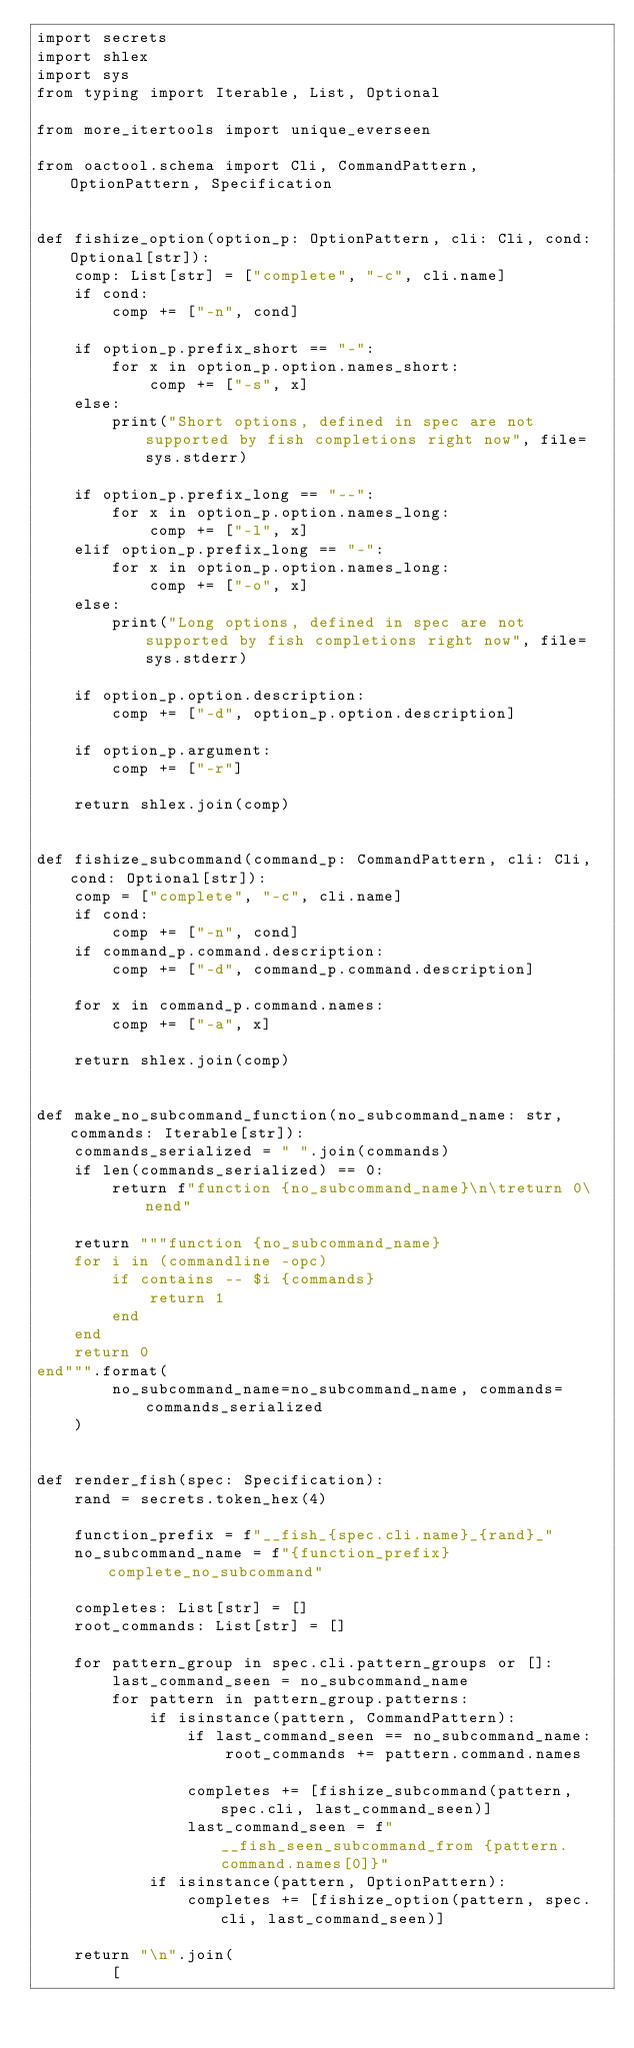<code> <loc_0><loc_0><loc_500><loc_500><_Python_>import secrets
import shlex
import sys
from typing import Iterable, List, Optional

from more_itertools import unique_everseen

from oactool.schema import Cli, CommandPattern, OptionPattern, Specification


def fishize_option(option_p: OptionPattern, cli: Cli, cond: Optional[str]):
    comp: List[str] = ["complete", "-c", cli.name]
    if cond:
        comp += ["-n", cond]

    if option_p.prefix_short == "-":
        for x in option_p.option.names_short:
            comp += ["-s", x]
    else:
        print("Short options, defined in spec are not supported by fish completions right now", file=sys.stderr)

    if option_p.prefix_long == "--":
        for x in option_p.option.names_long:
            comp += ["-l", x]
    elif option_p.prefix_long == "-":
        for x in option_p.option.names_long:
            comp += ["-o", x]
    else:
        print("Long options, defined in spec are not supported by fish completions right now", file=sys.stderr)

    if option_p.option.description:
        comp += ["-d", option_p.option.description]

    if option_p.argument:
        comp += ["-r"]

    return shlex.join(comp)


def fishize_subcommand(command_p: CommandPattern, cli: Cli, cond: Optional[str]):
    comp = ["complete", "-c", cli.name]
    if cond:
        comp += ["-n", cond]
    if command_p.command.description:
        comp += ["-d", command_p.command.description]

    for x in command_p.command.names:
        comp += ["-a", x]

    return shlex.join(comp)


def make_no_subcommand_function(no_subcommand_name: str, commands: Iterable[str]):
    commands_serialized = " ".join(commands)
    if len(commands_serialized) == 0:
        return f"function {no_subcommand_name}\n\treturn 0\nend"

    return """function {no_subcommand_name}
    for i in (commandline -opc)
        if contains -- $i {commands}
            return 1
        end
    end
    return 0
end""".format(
        no_subcommand_name=no_subcommand_name, commands=commands_serialized
    )


def render_fish(spec: Specification):
    rand = secrets.token_hex(4)

    function_prefix = f"__fish_{spec.cli.name}_{rand}_"
    no_subcommand_name = f"{function_prefix}complete_no_subcommand"

    completes: List[str] = []
    root_commands: List[str] = []

    for pattern_group in spec.cli.pattern_groups or []:
        last_command_seen = no_subcommand_name
        for pattern in pattern_group.patterns:
            if isinstance(pattern, CommandPattern):
                if last_command_seen == no_subcommand_name:
                    root_commands += pattern.command.names

                completes += [fishize_subcommand(pattern, spec.cli, last_command_seen)]
                last_command_seen = f"__fish_seen_subcommand_from {pattern.command.names[0]}"
            if isinstance(pattern, OptionPattern):
                completes += [fishize_option(pattern, spec.cli, last_command_seen)]

    return "\n".join(
        [</code> 